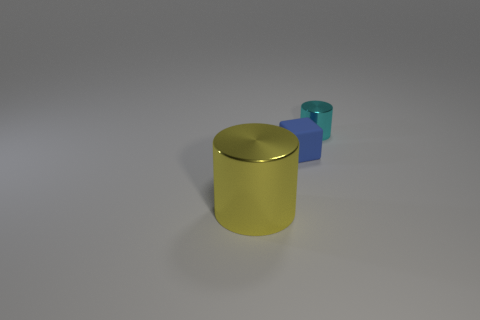Do the object that is behind the small blue thing and the big object have the same color?
Your answer should be compact. No. There is a tiny thing that is left of the cylinder behind the yellow cylinder; what shape is it?
Provide a succinct answer. Cube. How many things are either objects that are on the left side of the tiny cyan shiny object or tiny objects that are on the left side of the tiny shiny cylinder?
Your answer should be very brief. 2. Are there any other things that are the same color as the large object?
Give a very brief answer. No. There is a small cyan thing that is the same shape as the yellow object; what is it made of?
Offer a terse response. Metal. What number of other objects are there of the same size as the yellow thing?
Your response must be concise. 0. What is the material of the cyan cylinder?
Your response must be concise. Metal. Is the number of big yellow cylinders that are in front of the tiny metal thing greater than the number of red rubber cylinders?
Keep it short and to the point. Yes. Are any purple metallic things visible?
Offer a very short reply. No. What number of other objects are there of the same shape as the big metal thing?
Provide a succinct answer. 1. 